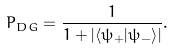<formula> <loc_0><loc_0><loc_500><loc_500>P _ { D G } = \frac { 1 } { 1 + | { \langle } { \psi } _ { + } | { \psi } _ { - } { \rangle } | } .</formula> 